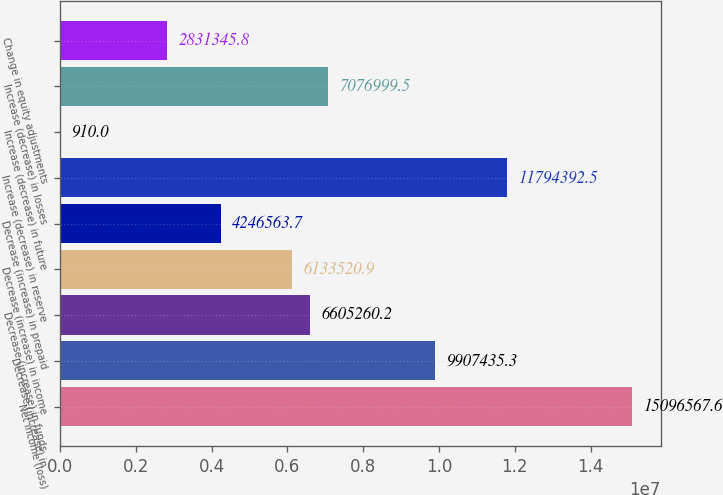Convert chart to OTSL. <chart><loc_0><loc_0><loc_500><loc_500><bar_chart><fcel>Net income (loss)<fcel>Decrease (increase) in<fcel>Decrease (increase) in funds<fcel>Decrease (increase) in income<fcel>Decrease (increase) in prepaid<fcel>Increase (decrease) in reserve<fcel>Increase (decrease) in future<fcel>Increase (decrease) in losses<fcel>Change in equity adjustments<nl><fcel>1.50966e+07<fcel>9.90744e+06<fcel>6.60526e+06<fcel>6.13352e+06<fcel>4.24656e+06<fcel>1.17944e+07<fcel>910<fcel>7.077e+06<fcel>2.83135e+06<nl></chart> 